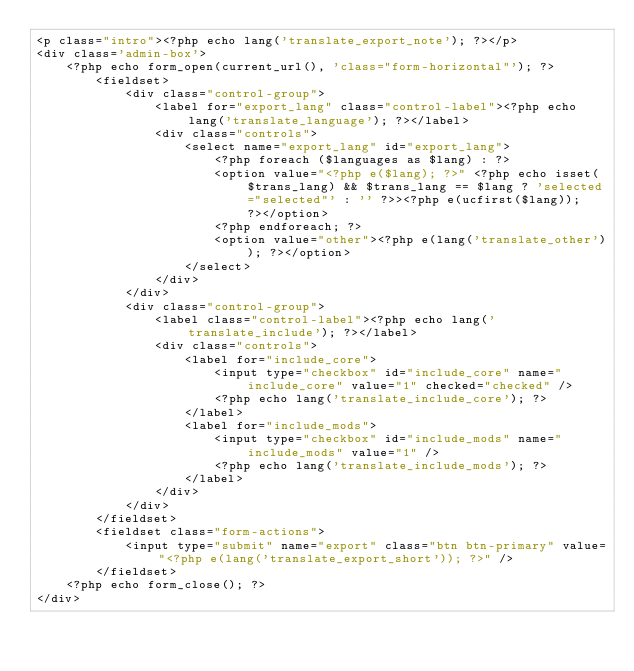<code> <loc_0><loc_0><loc_500><loc_500><_PHP_><p class="intro"><?php echo lang('translate_export_note'); ?></p>
<div class='admin-box'>
    <?php echo form_open(current_url(), 'class="form-horizontal"'); ?>
        <fieldset>
            <div class="control-group">
                <label for="export_lang" class="control-label"><?php echo lang('translate_language'); ?></label>
                <div class="controls">
                    <select name="export_lang" id="export_lang">
                        <?php foreach ($languages as $lang) : ?>
                        <option value="<?php e($lang); ?>" <?php echo isset($trans_lang) && $trans_lang == $lang ? 'selected="selected"' : '' ?>><?php e(ucfirst($lang)); ?></option>
                        <?php endforeach; ?>
                        <option value="other"><?php e(lang('translate_other')); ?></option>
                    </select>
                </div>
            </div>
            <div class="control-group">
                <label class="control-label"><?php echo lang('translate_include'); ?></label>
                <div class="controls">
                    <label for="include_core">
                        <input type="checkbox" id="include_core" name="include_core" value="1" checked="checked" />
                        <?php echo lang('translate_include_core'); ?>
                    </label>
                    <label for="include_mods">
                        <input type="checkbox" id="include_mods" name="include_mods" value="1" />
                        <?php echo lang('translate_include_mods'); ?>
                    </label>
                </div>
            </div>
        </fieldset>
        <fieldset class="form-actions">
            <input type="submit" name="export" class="btn btn-primary" value="<?php e(lang('translate_export_short')); ?>" />
        </fieldset>
    <?php echo form_close(); ?>
</div></code> 